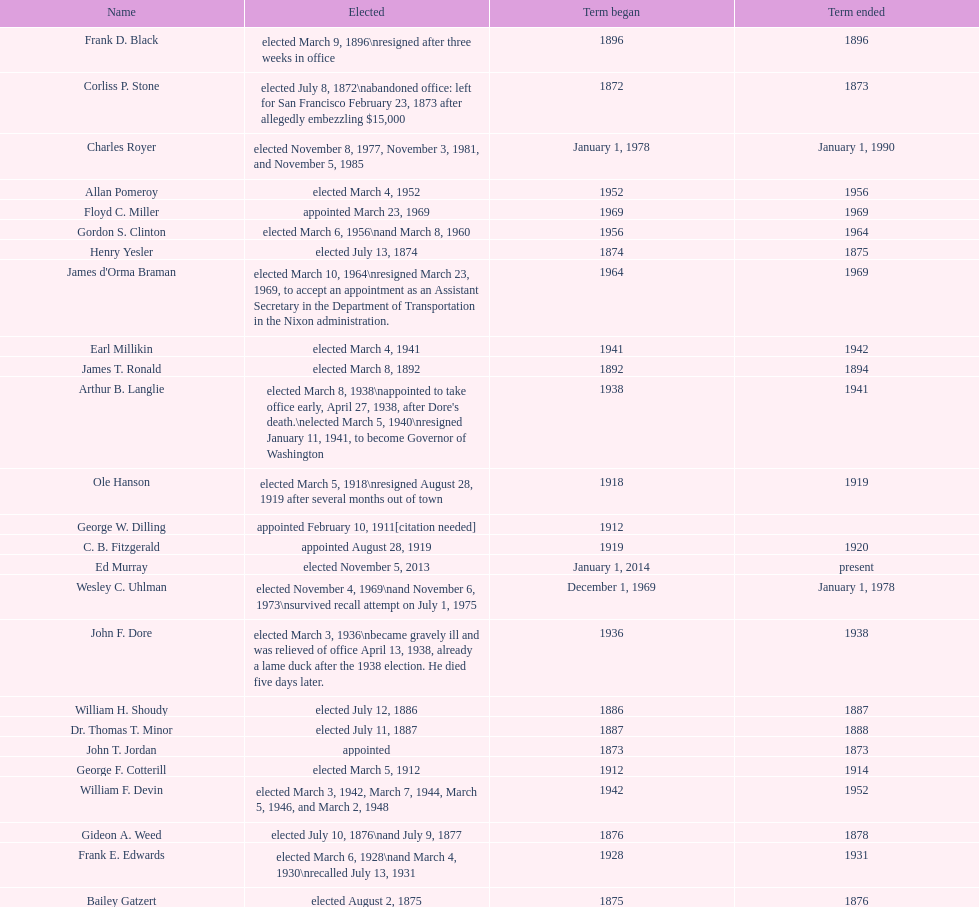Who was the only person elected in 1871? John T. Jordan. 